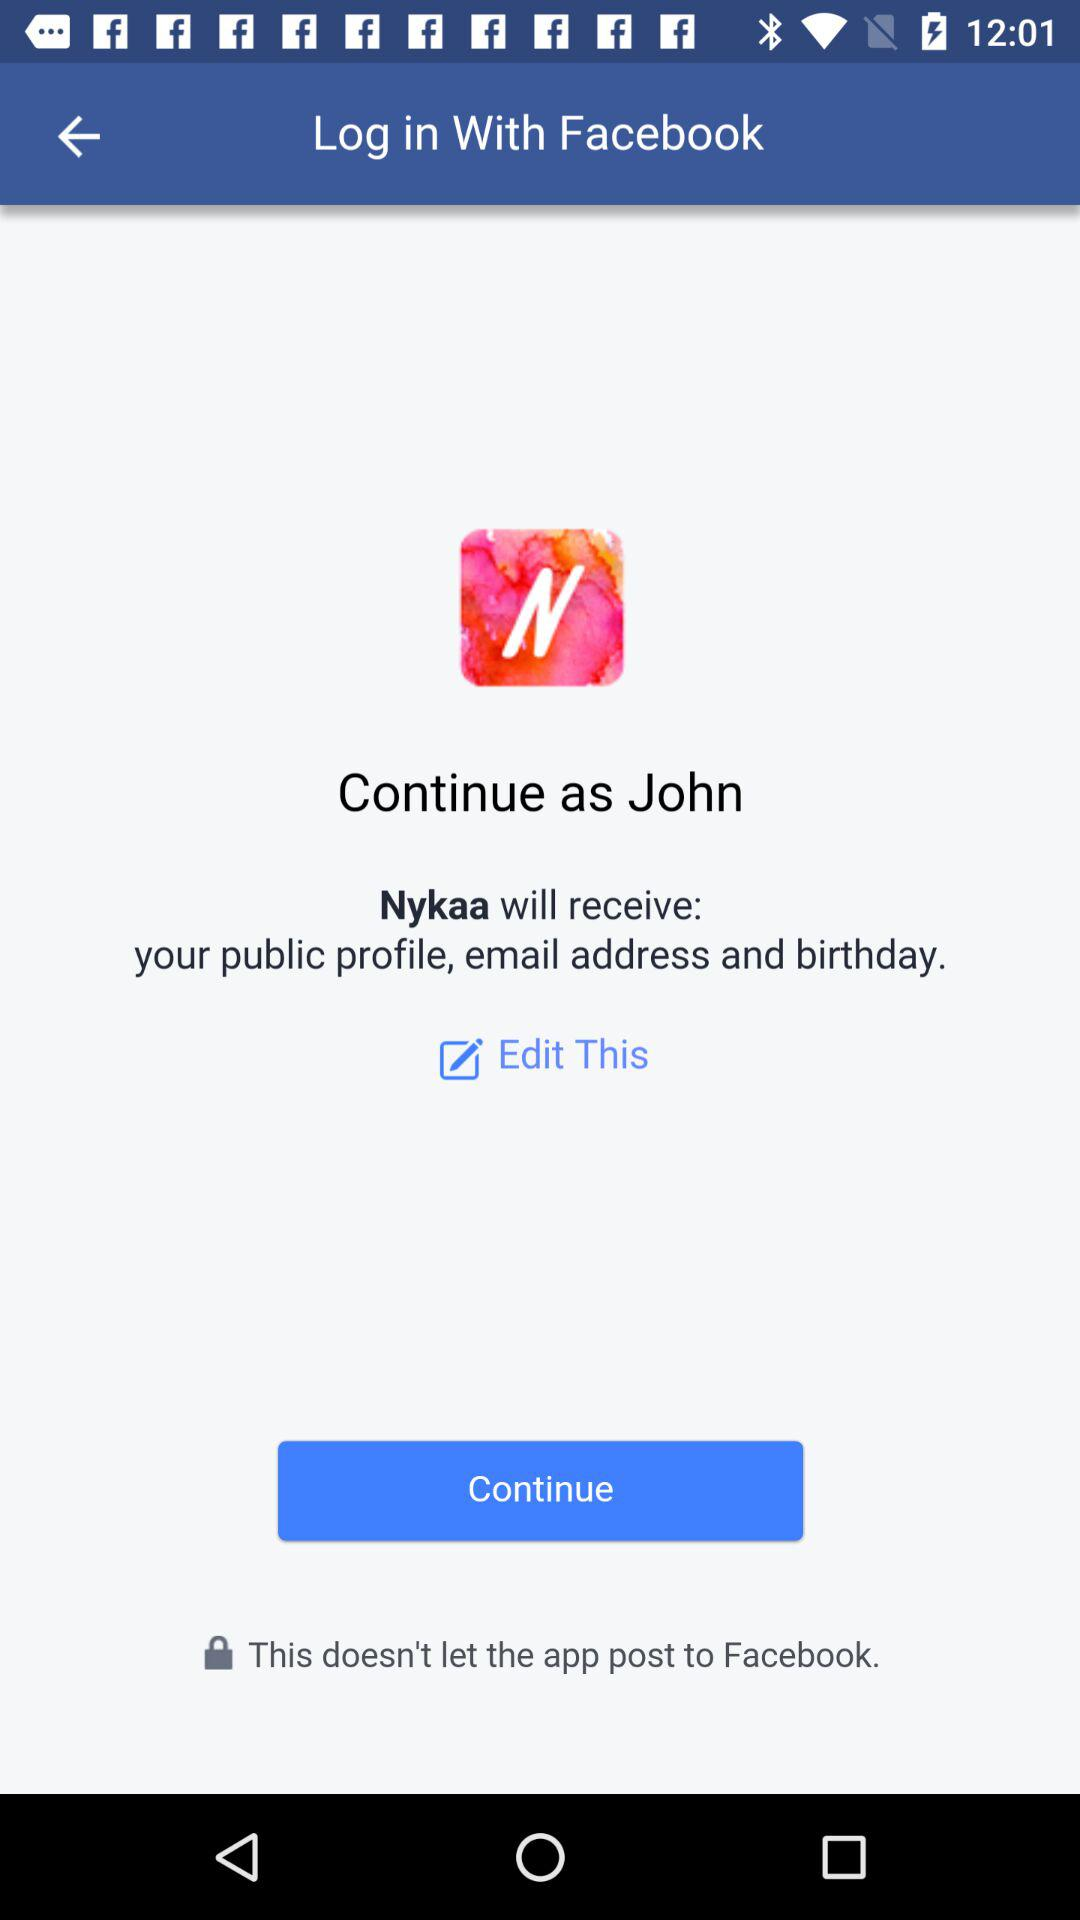What will "Nykaa" receive? "Nykaa" will receive your public profile, email address and birthday. 